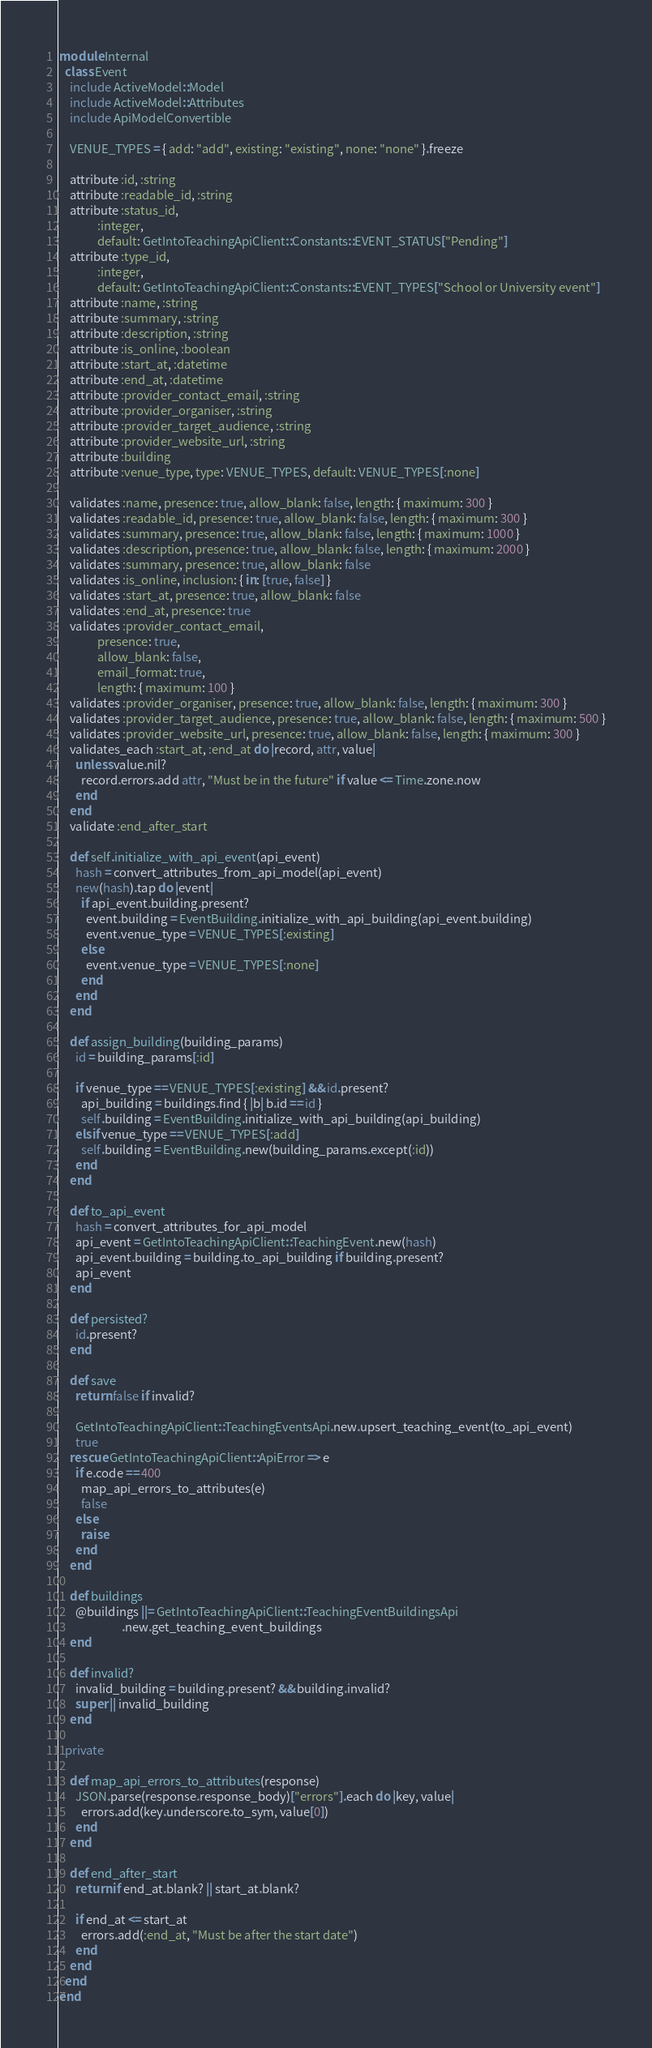<code> <loc_0><loc_0><loc_500><loc_500><_Ruby_>module Internal
  class Event
    include ActiveModel::Model
    include ActiveModel::Attributes
    include ApiModelConvertible

    VENUE_TYPES = { add: "add", existing: "existing", none: "none" }.freeze

    attribute :id, :string
    attribute :readable_id, :string
    attribute :status_id,
              :integer,
              default: GetIntoTeachingApiClient::Constants::EVENT_STATUS["Pending"]
    attribute :type_id,
              :integer,
              default: GetIntoTeachingApiClient::Constants::EVENT_TYPES["School or University event"]
    attribute :name, :string
    attribute :summary, :string
    attribute :description, :string
    attribute :is_online, :boolean
    attribute :start_at, :datetime
    attribute :end_at, :datetime
    attribute :provider_contact_email, :string
    attribute :provider_organiser, :string
    attribute :provider_target_audience, :string
    attribute :provider_website_url, :string
    attribute :building
    attribute :venue_type, type: VENUE_TYPES, default: VENUE_TYPES[:none]

    validates :name, presence: true, allow_blank: false, length: { maximum: 300 }
    validates :readable_id, presence: true, allow_blank: false, length: { maximum: 300 }
    validates :summary, presence: true, allow_blank: false, length: { maximum: 1000 }
    validates :description, presence: true, allow_blank: false, length: { maximum: 2000 }
    validates :summary, presence: true, allow_blank: false
    validates :is_online, inclusion: { in: [true, false] }
    validates :start_at, presence: true, allow_blank: false
    validates :end_at, presence: true
    validates :provider_contact_email,
              presence: true,
              allow_blank: false,
              email_format: true,
              length: { maximum: 100 }
    validates :provider_organiser, presence: true, allow_blank: false, length: { maximum: 300 }
    validates :provider_target_audience, presence: true, allow_blank: false, length: { maximum: 500 }
    validates :provider_website_url, presence: true, allow_blank: false, length: { maximum: 300 }
    validates_each :start_at, :end_at do |record, attr, value|
      unless value.nil?
        record.errors.add attr, "Must be in the future" if value <= Time.zone.now
      end
    end
    validate :end_after_start

    def self.initialize_with_api_event(api_event)
      hash = convert_attributes_from_api_model(api_event)
      new(hash).tap do |event|
        if api_event.building.present?
          event.building = EventBuilding.initialize_with_api_building(api_event.building)
          event.venue_type = VENUE_TYPES[:existing]
        else
          event.venue_type = VENUE_TYPES[:none]
        end
      end
    end

    def assign_building(building_params)
      id = building_params[:id]

      if venue_type == VENUE_TYPES[:existing] && id.present?
        api_building = buildings.find { |b| b.id == id }
        self.building = EventBuilding.initialize_with_api_building(api_building)
      elsif venue_type == VENUE_TYPES[:add]
        self.building = EventBuilding.new(building_params.except(:id))
      end
    end

    def to_api_event
      hash = convert_attributes_for_api_model
      api_event = GetIntoTeachingApiClient::TeachingEvent.new(hash)
      api_event.building = building.to_api_building if building.present?
      api_event
    end

    def persisted?
      id.present?
    end

    def save
      return false if invalid?

      GetIntoTeachingApiClient::TeachingEventsApi.new.upsert_teaching_event(to_api_event)
      true
    rescue GetIntoTeachingApiClient::ApiError => e
      if e.code == 400
        map_api_errors_to_attributes(e)
        false
      else
        raise
      end
    end

    def buildings
      @buildings ||= GetIntoTeachingApiClient::TeachingEventBuildingsApi
                       .new.get_teaching_event_buildings
    end

    def invalid?
      invalid_building = building.present? && building.invalid?
      super || invalid_building
    end

  private

    def map_api_errors_to_attributes(response)
      JSON.parse(response.response_body)["errors"].each do |key, value|
        errors.add(key.underscore.to_sym, value[0])
      end
    end

    def end_after_start
      return if end_at.blank? || start_at.blank?

      if end_at <= start_at
        errors.add(:end_at, "Must be after the start date")
      end
    end
  end
end
</code> 